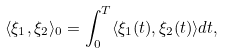Convert formula to latex. <formula><loc_0><loc_0><loc_500><loc_500>\langle \xi _ { 1 } , \xi _ { 2 } \rangle _ { 0 } = \int _ { 0 } ^ { T } \langle \xi _ { 1 } ( t ) , \xi _ { 2 } ( t ) \rangle d t ,</formula> 